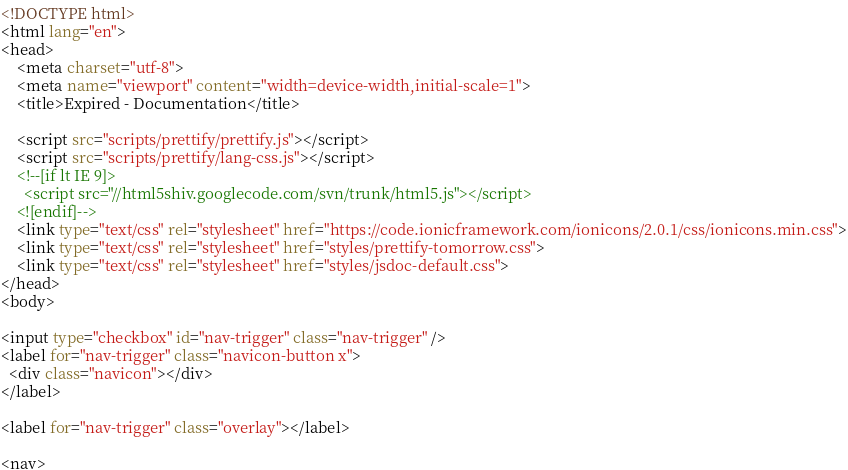<code> <loc_0><loc_0><loc_500><loc_500><_HTML_><!DOCTYPE html>
<html lang="en">
<head>
    <meta charset="utf-8">
    <meta name="viewport" content="width=device-width,initial-scale=1">
    <title>Expired - Documentation</title>

    <script src="scripts/prettify/prettify.js"></script>
    <script src="scripts/prettify/lang-css.js"></script>
    <!--[if lt IE 9]>
      <script src="//html5shiv.googlecode.com/svn/trunk/html5.js"></script>
    <![endif]-->
    <link type="text/css" rel="stylesheet" href="https://code.ionicframework.com/ionicons/2.0.1/css/ionicons.min.css">
    <link type="text/css" rel="stylesheet" href="styles/prettify-tomorrow.css">
    <link type="text/css" rel="stylesheet" href="styles/jsdoc-default.css">
</head>
<body>

<input type="checkbox" id="nav-trigger" class="nav-trigger" />
<label for="nav-trigger" class="navicon-button x">
  <div class="navicon"></div>
</label>

<label for="nav-trigger" class="overlay"></label>

<nav></code> 